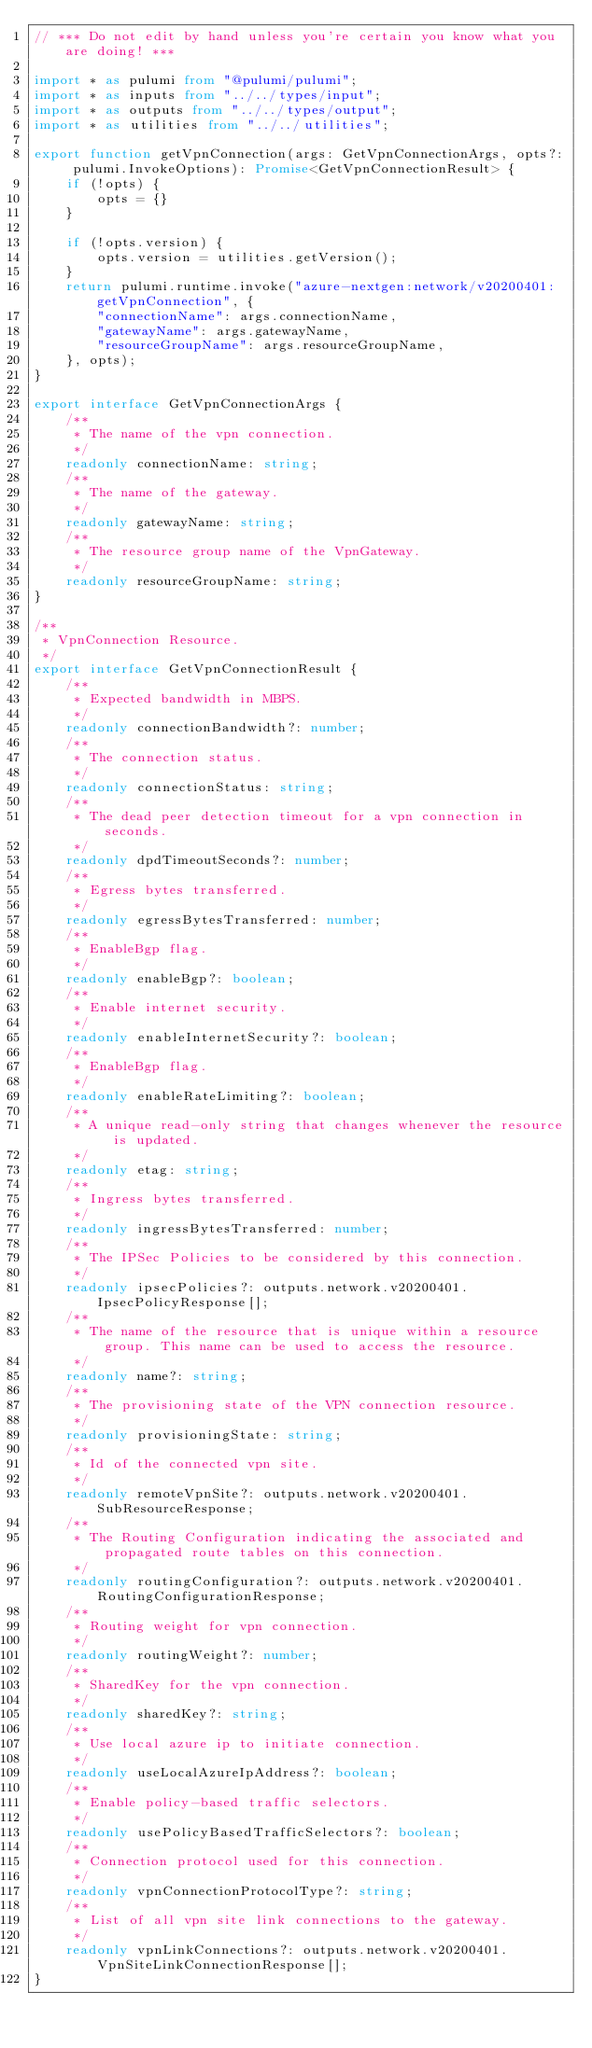<code> <loc_0><loc_0><loc_500><loc_500><_TypeScript_>// *** Do not edit by hand unless you're certain you know what you are doing! ***

import * as pulumi from "@pulumi/pulumi";
import * as inputs from "../../types/input";
import * as outputs from "../../types/output";
import * as utilities from "../../utilities";

export function getVpnConnection(args: GetVpnConnectionArgs, opts?: pulumi.InvokeOptions): Promise<GetVpnConnectionResult> {
    if (!opts) {
        opts = {}
    }

    if (!opts.version) {
        opts.version = utilities.getVersion();
    }
    return pulumi.runtime.invoke("azure-nextgen:network/v20200401:getVpnConnection", {
        "connectionName": args.connectionName,
        "gatewayName": args.gatewayName,
        "resourceGroupName": args.resourceGroupName,
    }, opts);
}

export interface GetVpnConnectionArgs {
    /**
     * The name of the vpn connection.
     */
    readonly connectionName: string;
    /**
     * The name of the gateway.
     */
    readonly gatewayName: string;
    /**
     * The resource group name of the VpnGateway.
     */
    readonly resourceGroupName: string;
}

/**
 * VpnConnection Resource.
 */
export interface GetVpnConnectionResult {
    /**
     * Expected bandwidth in MBPS.
     */
    readonly connectionBandwidth?: number;
    /**
     * The connection status.
     */
    readonly connectionStatus: string;
    /**
     * The dead peer detection timeout for a vpn connection in seconds.
     */
    readonly dpdTimeoutSeconds?: number;
    /**
     * Egress bytes transferred.
     */
    readonly egressBytesTransferred: number;
    /**
     * EnableBgp flag.
     */
    readonly enableBgp?: boolean;
    /**
     * Enable internet security.
     */
    readonly enableInternetSecurity?: boolean;
    /**
     * EnableBgp flag.
     */
    readonly enableRateLimiting?: boolean;
    /**
     * A unique read-only string that changes whenever the resource is updated.
     */
    readonly etag: string;
    /**
     * Ingress bytes transferred.
     */
    readonly ingressBytesTransferred: number;
    /**
     * The IPSec Policies to be considered by this connection.
     */
    readonly ipsecPolicies?: outputs.network.v20200401.IpsecPolicyResponse[];
    /**
     * The name of the resource that is unique within a resource group. This name can be used to access the resource.
     */
    readonly name?: string;
    /**
     * The provisioning state of the VPN connection resource.
     */
    readonly provisioningState: string;
    /**
     * Id of the connected vpn site.
     */
    readonly remoteVpnSite?: outputs.network.v20200401.SubResourceResponse;
    /**
     * The Routing Configuration indicating the associated and propagated route tables on this connection.
     */
    readonly routingConfiguration?: outputs.network.v20200401.RoutingConfigurationResponse;
    /**
     * Routing weight for vpn connection.
     */
    readonly routingWeight?: number;
    /**
     * SharedKey for the vpn connection.
     */
    readonly sharedKey?: string;
    /**
     * Use local azure ip to initiate connection.
     */
    readonly useLocalAzureIpAddress?: boolean;
    /**
     * Enable policy-based traffic selectors.
     */
    readonly usePolicyBasedTrafficSelectors?: boolean;
    /**
     * Connection protocol used for this connection.
     */
    readonly vpnConnectionProtocolType?: string;
    /**
     * List of all vpn site link connections to the gateway.
     */
    readonly vpnLinkConnections?: outputs.network.v20200401.VpnSiteLinkConnectionResponse[];
}
</code> 